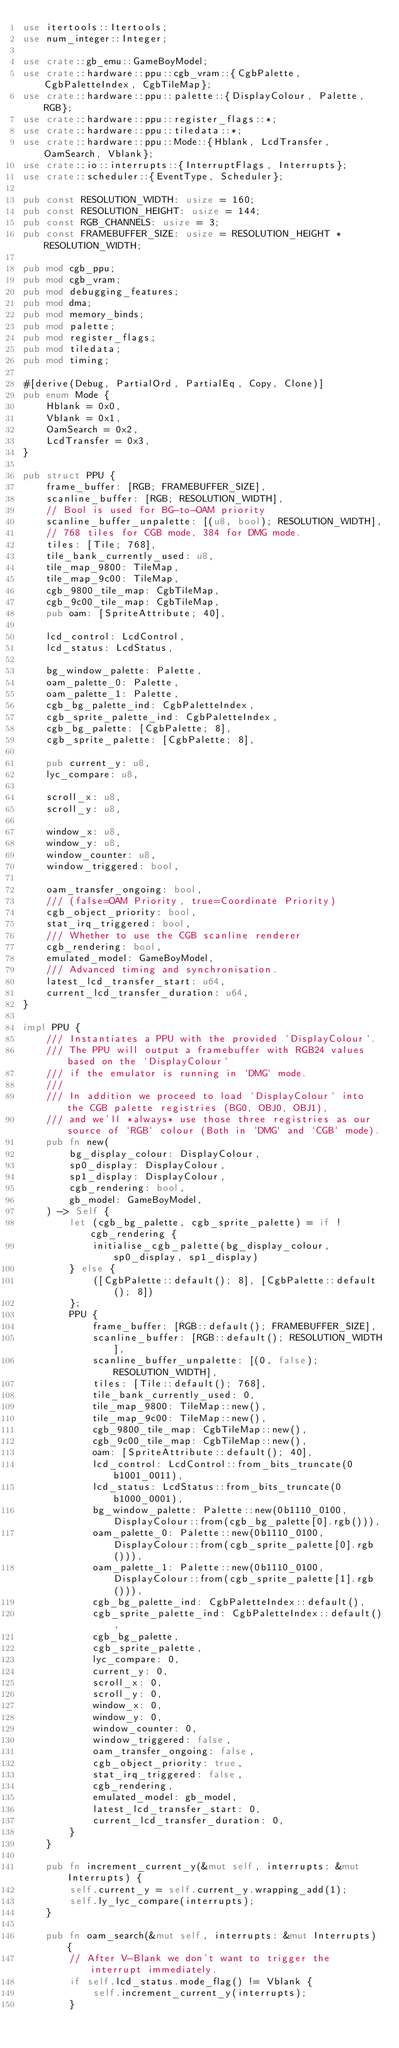Convert code to text. <code><loc_0><loc_0><loc_500><loc_500><_Rust_>use itertools::Itertools;
use num_integer::Integer;

use crate::gb_emu::GameBoyModel;
use crate::hardware::ppu::cgb_vram::{CgbPalette, CgbPaletteIndex, CgbTileMap};
use crate::hardware::ppu::palette::{DisplayColour, Palette, RGB};
use crate::hardware::ppu::register_flags::*;
use crate::hardware::ppu::tiledata::*;
use crate::hardware::ppu::Mode::{Hblank, LcdTransfer, OamSearch, Vblank};
use crate::io::interrupts::{InterruptFlags, Interrupts};
use crate::scheduler::{EventType, Scheduler};

pub const RESOLUTION_WIDTH: usize = 160;
pub const RESOLUTION_HEIGHT: usize = 144;
pub const RGB_CHANNELS: usize = 3;
pub const FRAMEBUFFER_SIZE: usize = RESOLUTION_HEIGHT * RESOLUTION_WIDTH;

pub mod cgb_ppu;
pub mod cgb_vram;
pub mod debugging_features;
pub mod dma;
pub mod memory_binds;
pub mod palette;
pub mod register_flags;
pub mod tiledata;
pub mod timing;

#[derive(Debug, PartialOrd, PartialEq, Copy, Clone)]
pub enum Mode {
    Hblank = 0x0,
    Vblank = 0x1,
    OamSearch = 0x2,
    LcdTransfer = 0x3,
}

pub struct PPU {
    frame_buffer: [RGB; FRAMEBUFFER_SIZE],
    scanline_buffer: [RGB; RESOLUTION_WIDTH],
    // Bool is used for BG-to-OAM priority
    scanline_buffer_unpalette: [(u8, bool); RESOLUTION_WIDTH],
    // 768 tiles for CGB mode, 384 for DMG mode.
    tiles: [Tile; 768],
    tile_bank_currently_used: u8,
    tile_map_9800: TileMap,
    tile_map_9c00: TileMap,
    cgb_9800_tile_map: CgbTileMap,
    cgb_9c00_tile_map: CgbTileMap,
    pub oam: [SpriteAttribute; 40],

    lcd_control: LcdControl,
    lcd_status: LcdStatus,

    bg_window_palette: Palette,
    oam_palette_0: Palette,
    oam_palette_1: Palette,
    cgb_bg_palette_ind: CgbPaletteIndex,
    cgb_sprite_palette_ind: CgbPaletteIndex,
    cgb_bg_palette: [CgbPalette; 8],
    cgb_sprite_palette: [CgbPalette; 8],

    pub current_y: u8,
    lyc_compare: u8,

    scroll_x: u8,
    scroll_y: u8,

    window_x: u8,
    window_y: u8,
    window_counter: u8,
    window_triggered: bool,

    oam_transfer_ongoing: bool,
    /// (false=OAM Priority, true=Coordinate Priority)
    cgb_object_priority: bool,
    stat_irq_triggered: bool,
    /// Whether to use the CGB scanline renderer
    cgb_rendering: bool,
    emulated_model: GameBoyModel,
    /// Advanced timing and synchronisation.
    latest_lcd_transfer_start: u64,
    current_lcd_transfer_duration: u64,
}

impl PPU {
    /// Instantiates a PPU with the provided `DisplayColour`.
    /// The PPU will output a framebuffer with RGB24 values based on the `DisplayColour`
    /// if the emulator is running in `DMG` mode.
    ///
    /// In addition we proceed to load `DisplayColour` into the CGB palette registries (BG0, OBJ0, OBJ1),
    /// and we'll *always* use those three registries as our source of `RGB` colour (Both in `DMG` and `CGB` mode).
    pub fn new(
        bg_display_colour: DisplayColour,
        sp0_display: DisplayColour,
        sp1_display: DisplayColour,
        cgb_rendering: bool,
        gb_model: GameBoyModel,
    ) -> Self {
        let (cgb_bg_palette, cgb_sprite_palette) = if !cgb_rendering {
            initialise_cgb_palette(bg_display_colour, sp0_display, sp1_display)
        } else {
            ([CgbPalette::default(); 8], [CgbPalette::default(); 8])
        };
        PPU {
            frame_buffer: [RGB::default(); FRAMEBUFFER_SIZE],
            scanline_buffer: [RGB::default(); RESOLUTION_WIDTH],
            scanline_buffer_unpalette: [(0, false); RESOLUTION_WIDTH],
            tiles: [Tile::default(); 768],
            tile_bank_currently_used: 0,
            tile_map_9800: TileMap::new(),
            tile_map_9c00: TileMap::new(),
            cgb_9800_tile_map: CgbTileMap::new(),
            cgb_9c00_tile_map: CgbTileMap::new(),
            oam: [SpriteAttribute::default(); 40],
            lcd_control: LcdControl::from_bits_truncate(0b1001_0011),
            lcd_status: LcdStatus::from_bits_truncate(0b1000_0001),
            bg_window_palette: Palette::new(0b1110_0100, DisplayColour::from(cgb_bg_palette[0].rgb())),
            oam_palette_0: Palette::new(0b1110_0100, DisplayColour::from(cgb_sprite_palette[0].rgb())),
            oam_palette_1: Palette::new(0b1110_0100, DisplayColour::from(cgb_sprite_palette[1].rgb())),
            cgb_bg_palette_ind: CgbPaletteIndex::default(),
            cgb_sprite_palette_ind: CgbPaletteIndex::default(),
            cgb_bg_palette,
            cgb_sprite_palette,
            lyc_compare: 0,
            current_y: 0,
            scroll_x: 0,
            scroll_y: 0,
            window_x: 0,
            window_y: 0,
            window_counter: 0,
            window_triggered: false,
            oam_transfer_ongoing: false,
            cgb_object_priority: true,
            stat_irq_triggered: false,
            cgb_rendering,
            emulated_model: gb_model,
            latest_lcd_transfer_start: 0,
            current_lcd_transfer_duration: 0,
        }
    }

    pub fn increment_current_y(&mut self, interrupts: &mut Interrupts) {
        self.current_y = self.current_y.wrapping_add(1);
        self.ly_lyc_compare(interrupts);
    }

    pub fn oam_search(&mut self, interrupts: &mut Interrupts) {
        // After V-Blank we don't want to trigger the interrupt immediately.
        if self.lcd_status.mode_flag() != Vblank {
            self.increment_current_y(interrupts);
        }
</code> 